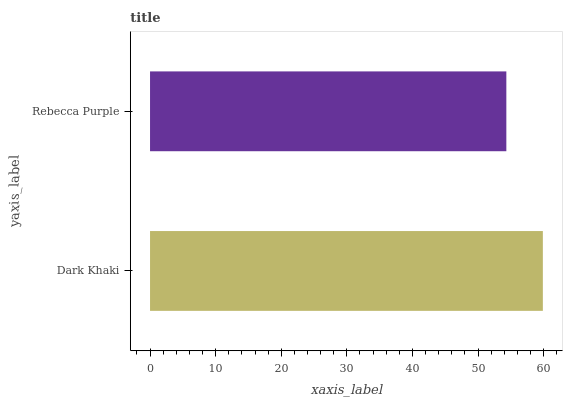Is Rebecca Purple the minimum?
Answer yes or no. Yes. Is Dark Khaki the maximum?
Answer yes or no. Yes. Is Rebecca Purple the maximum?
Answer yes or no. No. Is Dark Khaki greater than Rebecca Purple?
Answer yes or no. Yes. Is Rebecca Purple less than Dark Khaki?
Answer yes or no. Yes. Is Rebecca Purple greater than Dark Khaki?
Answer yes or no. No. Is Dark Khaki less than Rebecca Purple?
Answer yes or no. No. Is Dark Khaki the high median?
Answer yes or no. Yes. Is Rebecca Purple the low median?
Answer yes or no. Yes. Is Rebecca Purple the high median?
Answer yes or no. No. Is Dark Khaki the low median?
Answer yes or no. No. 